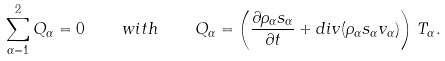<formula> <loc_0><loc_0><loc_500><loc_500>\sum _ { \alpha = 1 } ^ { 2 } Q _ { \alpha } = 0 \quad w i t h \quad Q _ { \alpha } = \left ( \frac { \partial \rho _ { \alpha } s _ { \alpha } } { \partial t } + { d i v } ( \rho _ { \alpha } s _ { \alpha } v _ { \alpha } ) \right ) \, T _ { \alpha } .</formula> 